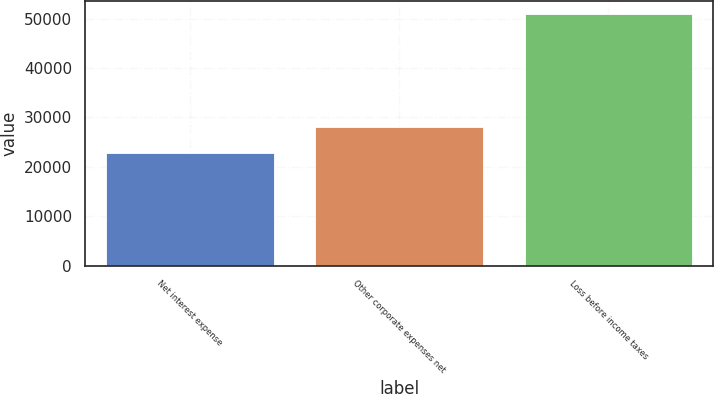Convert chart. <chart><loc_0><loc_0><loc_500><loc_500><bar_chart><fcel>Net interest expense<fcel>Other corporate expenses net<fcel>Loss before income taxes<nl><fcel>22824<fcel>28160<fcel>50984<nl></chart> 